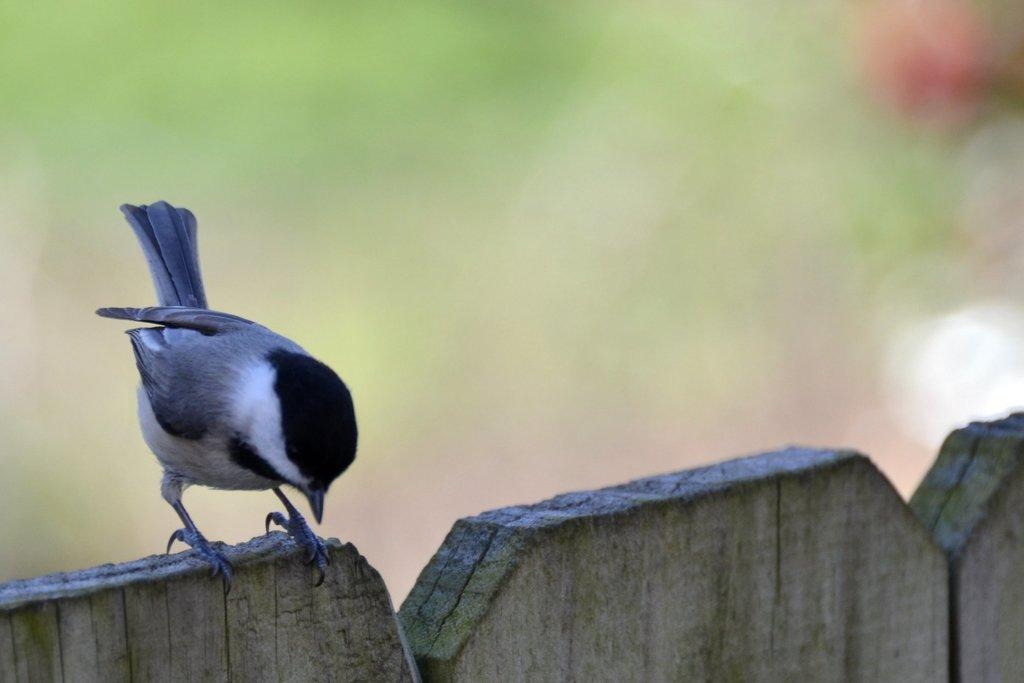What type of animal can be seen in the image? There is a bird in the image. Where is the bird located? The bird is standing on a wooden fence. What type of pear is being used in the machine in the image? There is no pear or machine present in the image; it features a bird standing on a wooden fence. 